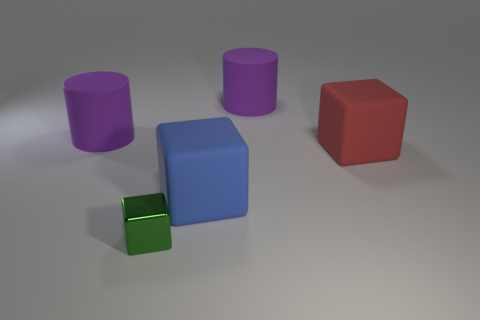Subtract all large blocks. How many blocks are left? 1 Add 1 large cylinders. How many objects exist? 6 Subtract all blocks. How many objects are left? 2 Add 4 purple matte cylinders. How many purple matte cylinders are left? 6 Add 3 red rubber objects. How many red rubber objects exist? 4 Subtract 0 yellow spheres. How many objects are left? 5 Subtract all rubber cylinders. Subtract all red rubber things. How many objects are left? 2 